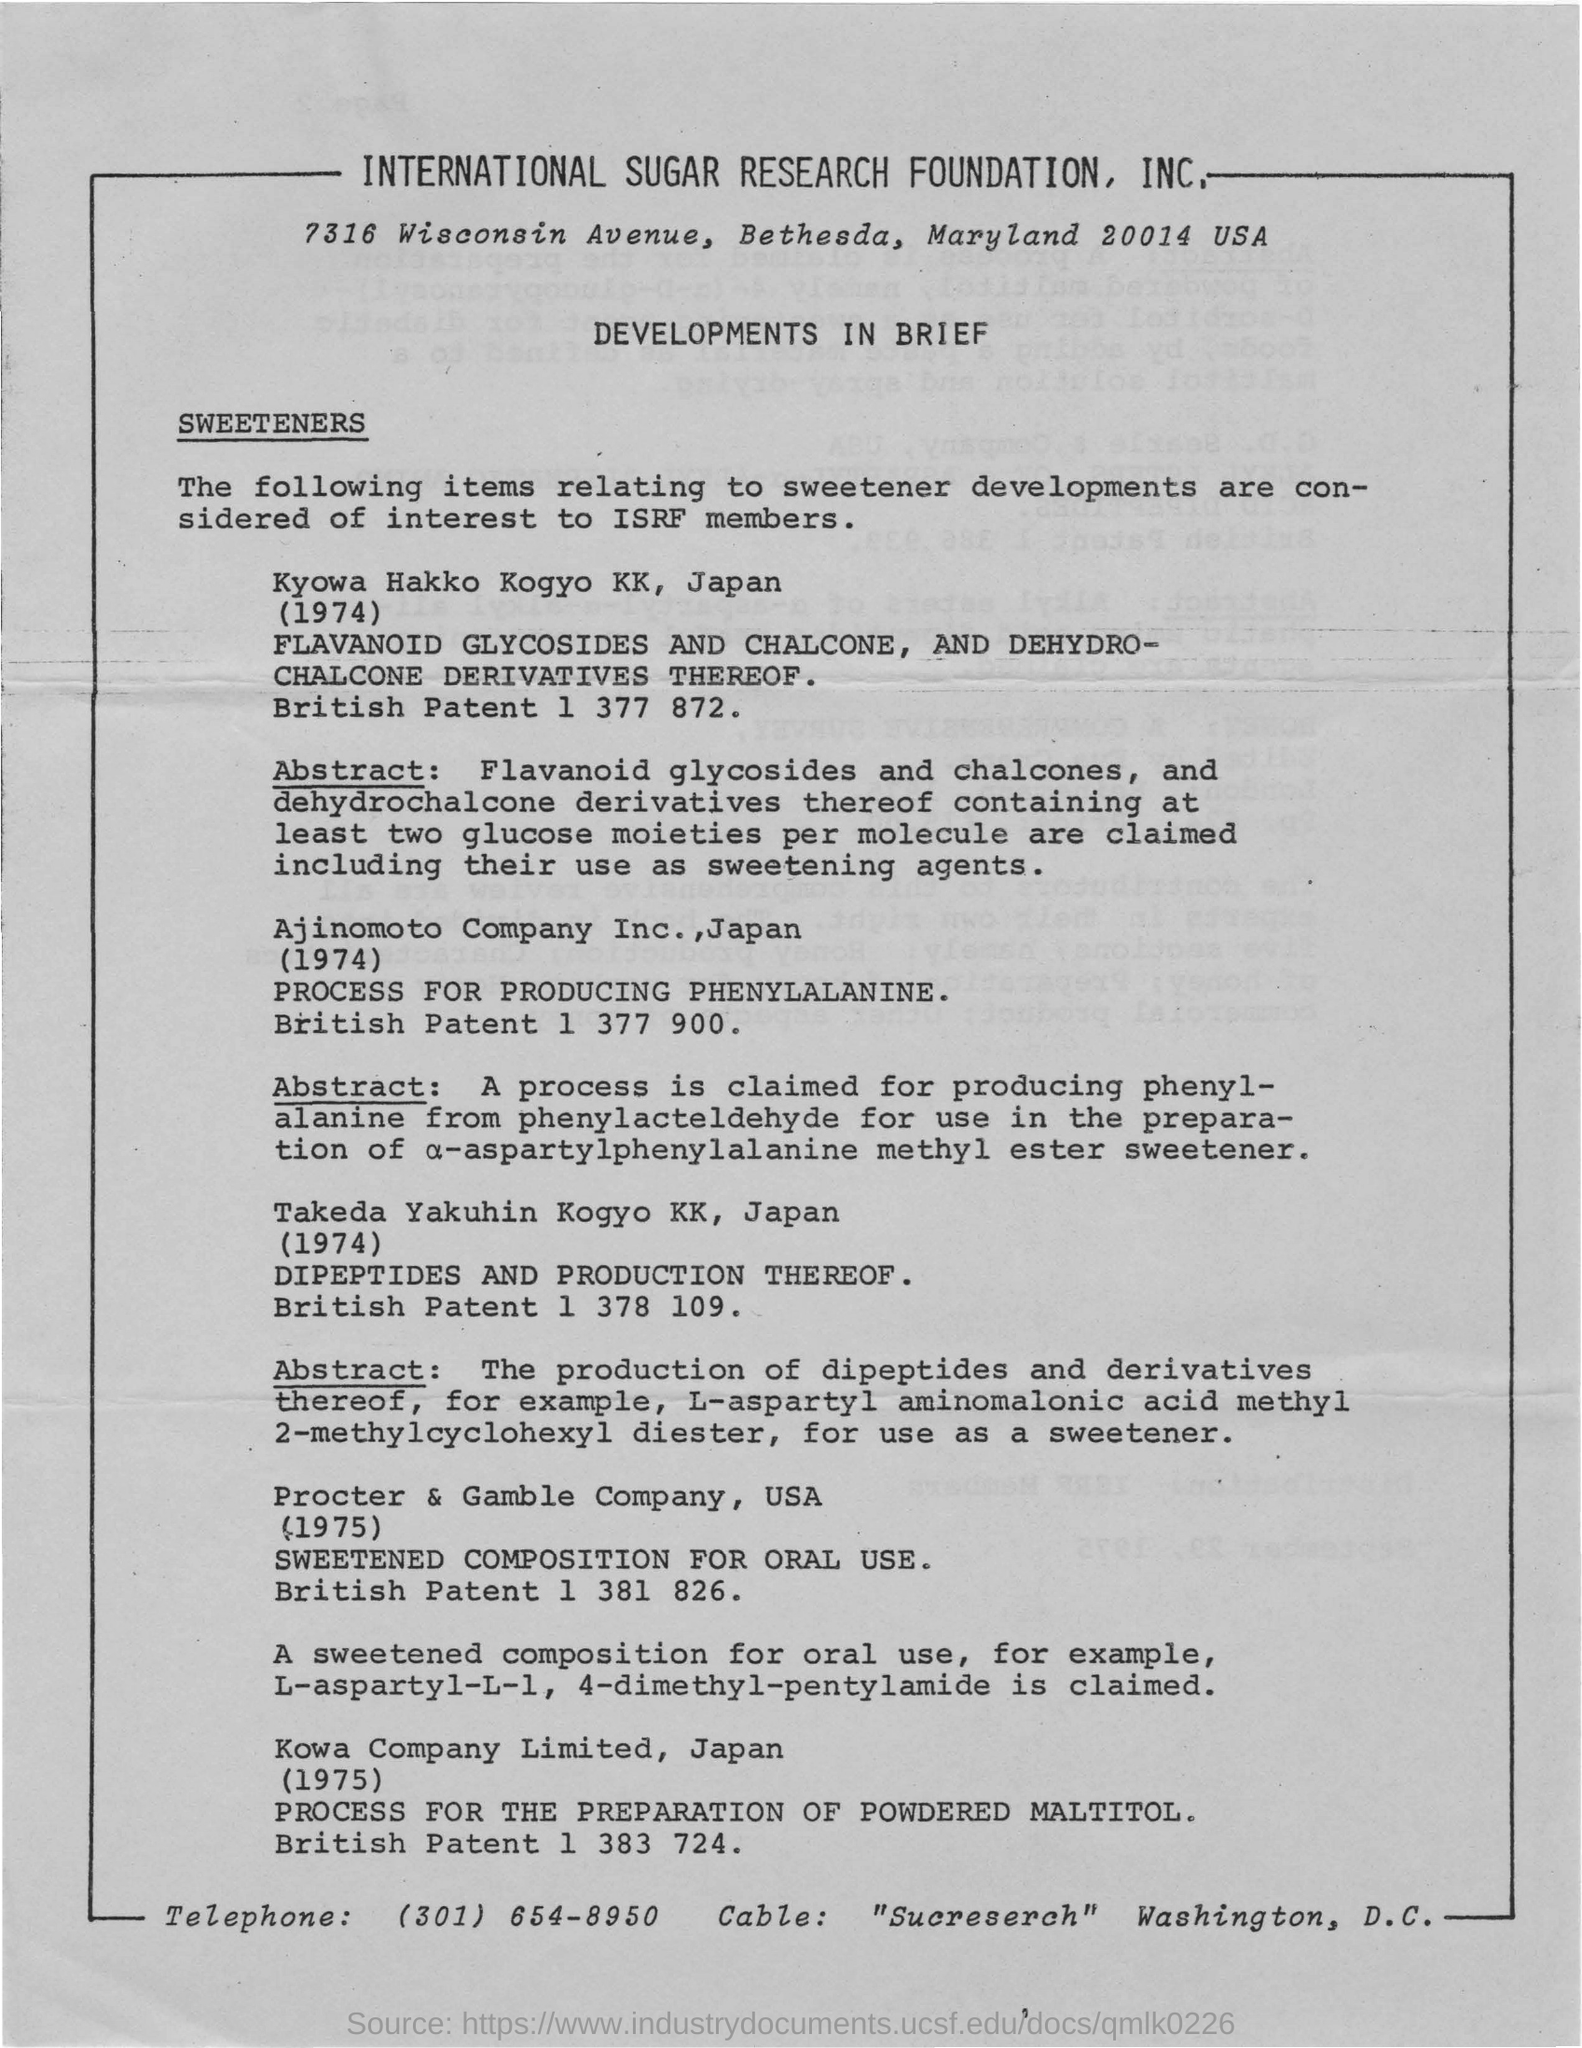Outline some significant characteristics in this image. The International Sugar Research Foundation, Inc. is mentioned at the top of the page. Kowa Company Limited, a Japanese company, has developed a sweetened oral composition called L-aspartyl-L-1,4-dimethyl-pentylamide. I have received a cable that reads 'Sucreserch' from the city of Washington, D.C. The telephone number provided at the bottom is (301) 654-8950. The patent number for DIPEPTIDES AND PRODUCTION THEREOF is British Patent 1 378 109. 